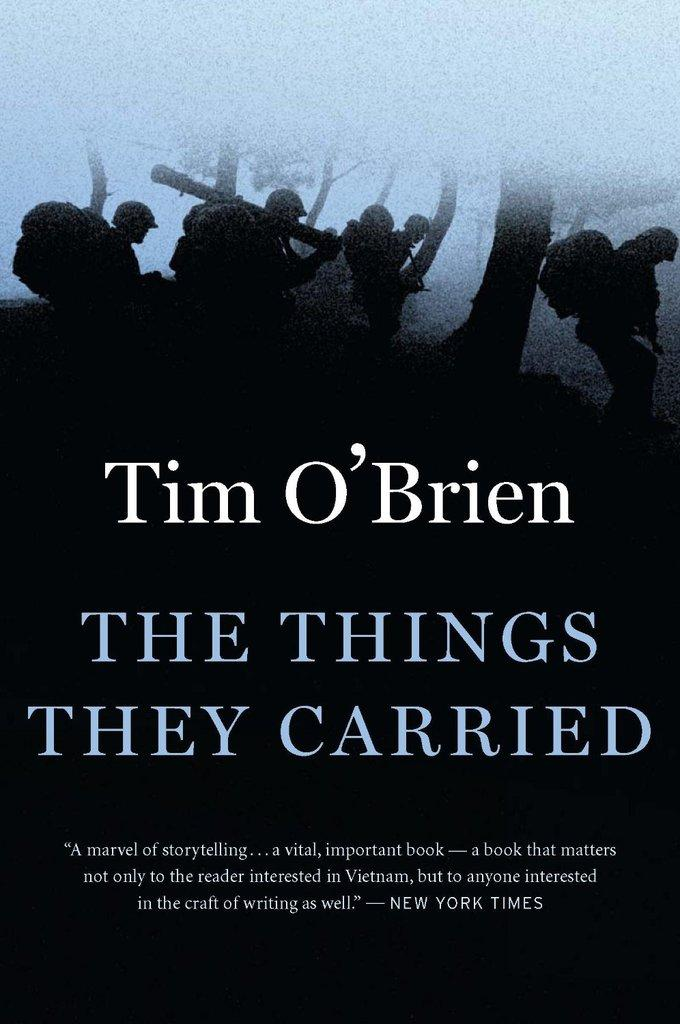Provide a one-sentence caption for the provided image. The things they carried book that was featured in new york times. 